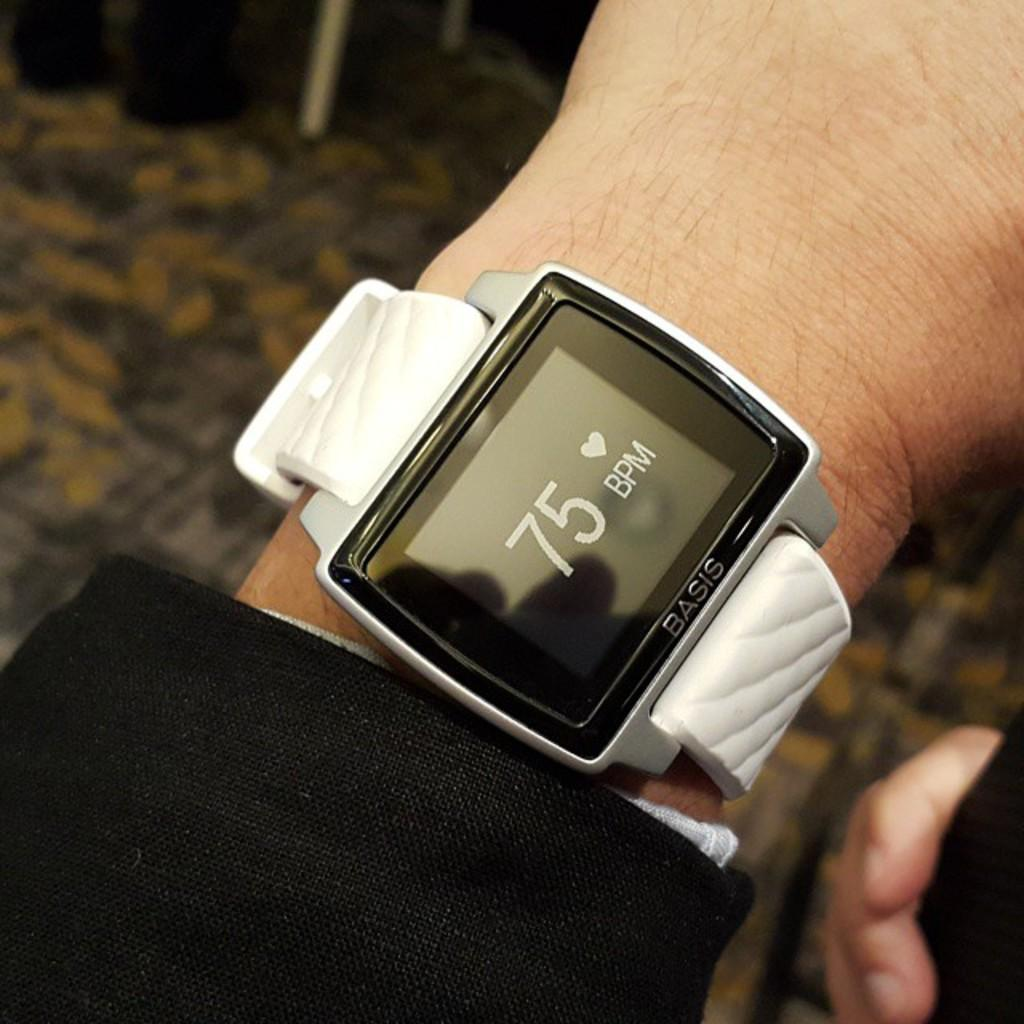<image>
Render a clear and concise summary of the photo. A watch has a screen with 75 bpm showing on it. 